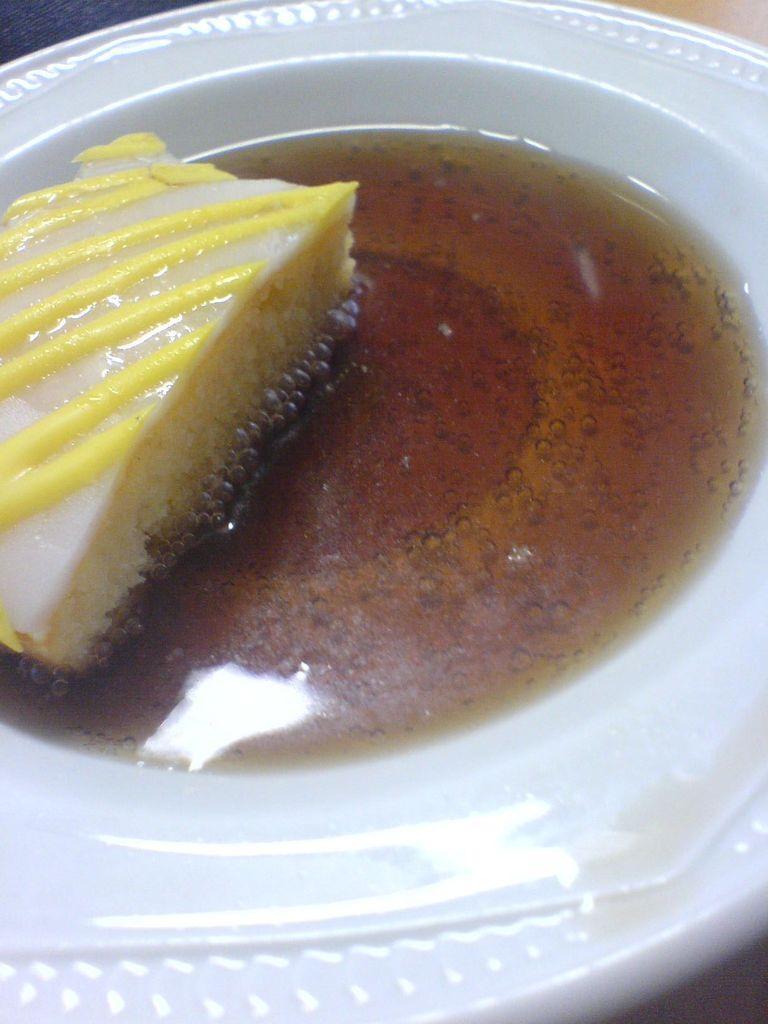Describe this image in one or two sentences. In this image we can see a plate containing food. 